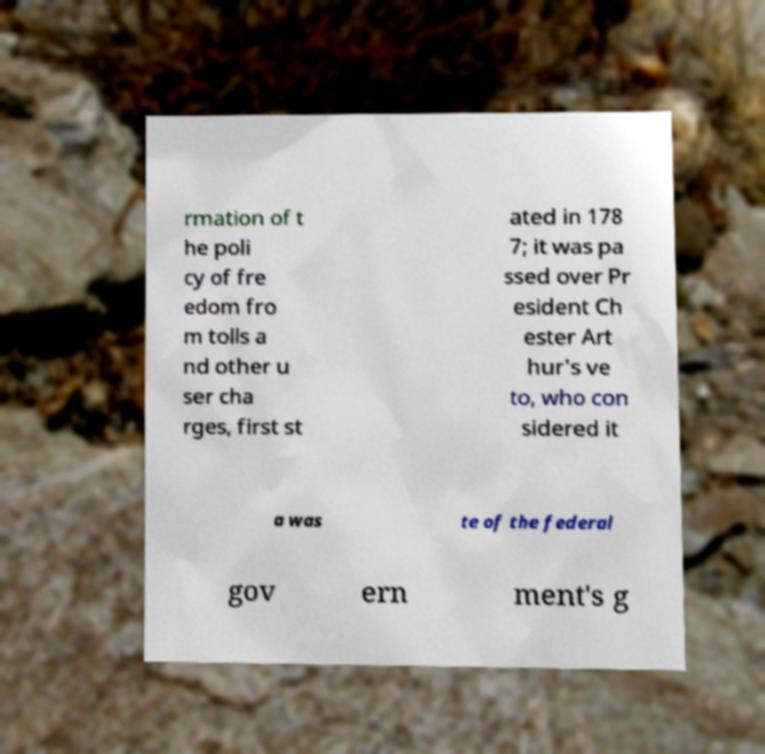Could you assist in decoding the text presented in this image and type it out clearly? rmation of t he poli cy of fre edom fro m tolls a nd other u ser cha rges, first st ated in 178 7; it was pa ssed over Pr esident Ch ester Art hur's ve to, who con sidered it a was te of the federal gov ern ment's g 